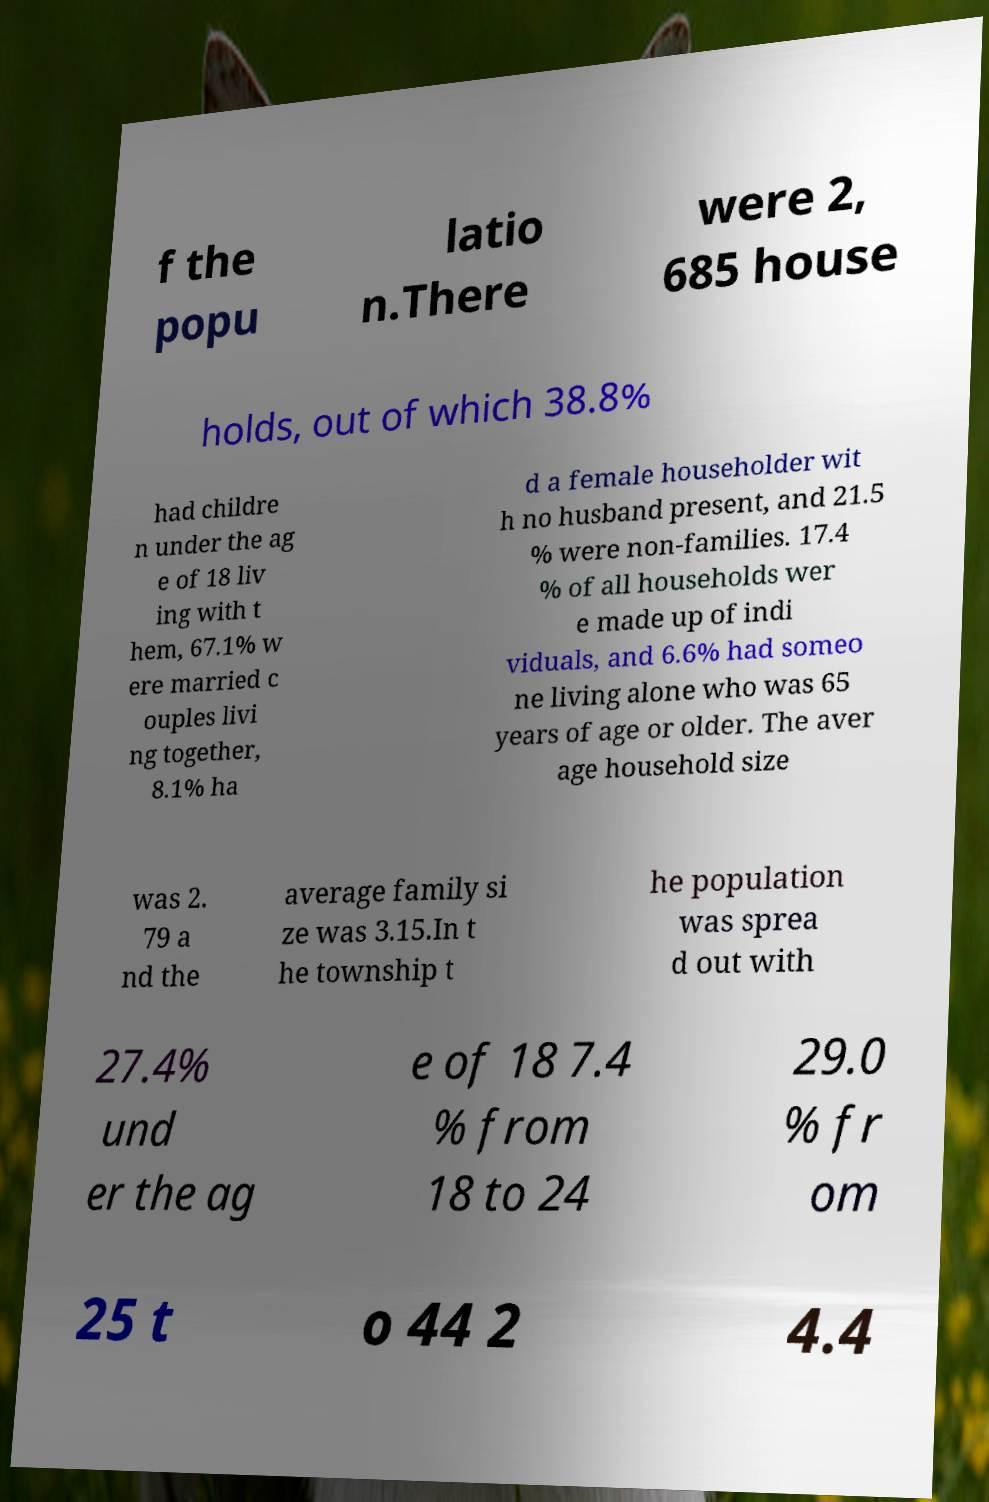What messages or text are displayed in this image? I need them in a readable, typed format. f the popu latio n.There were 2, 685 house holds, out of which 38.8% had childre n under the ag e of 18 liv ing with t hem, 67.1% w ere married c ouples livi ng together, 8.1% ha d a female householder wit h no husband present, and 21.5 % were non-families. 17.4 % of all households wer e made up of indi viduals, and 6.6% had someo ne living alone who was 65 years of age or older. The aver age household size was 2. 79 a nd the average family si ze was 3.15.In t he township t he population was sprea d out with 27.4% und er the ag e of 18 7.4 % from 18 to 24 29.0 % fr om 25 t o 44 2 4.4 